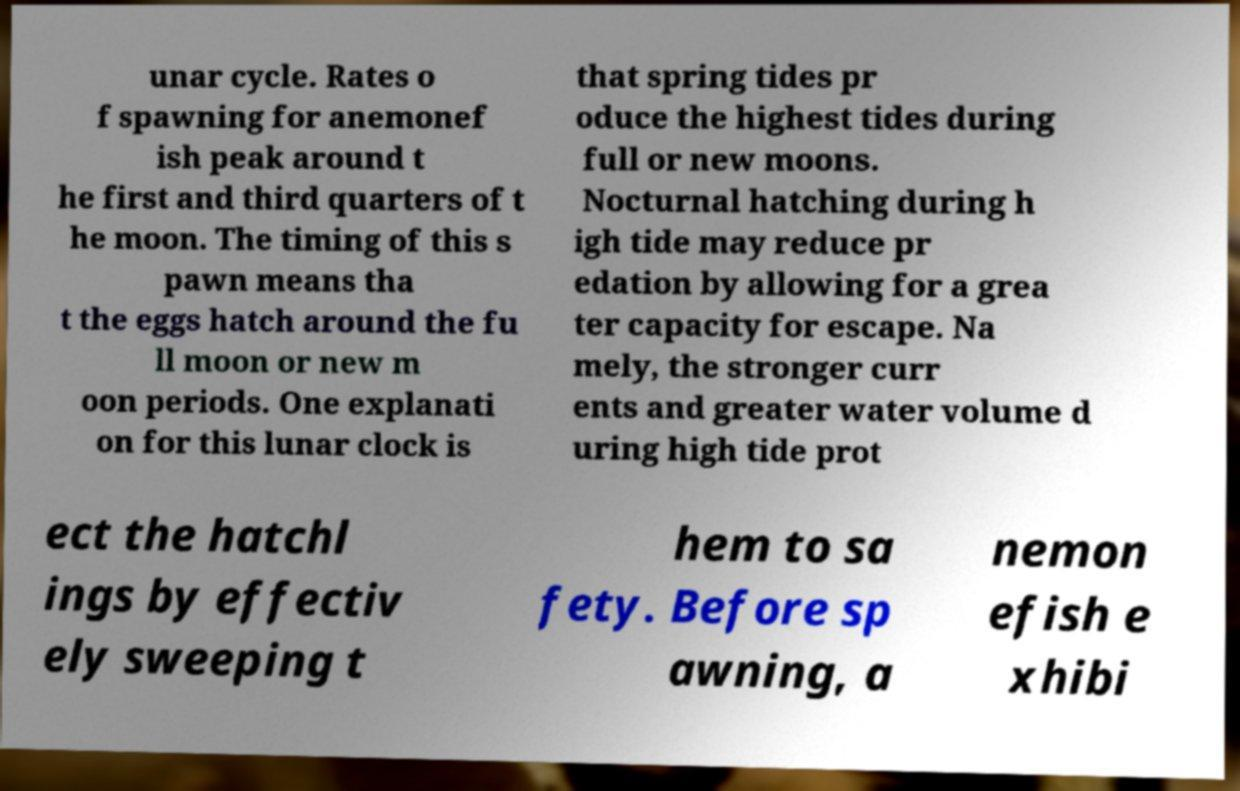Can you accurately transcribe the text from the provided image for me? unar cycle. Rates o f spawning for anemonef ish peak around t he first and third quarters of t he moon. The timing of this s pawn means tha t the eggs hatch around the fu ll moon or new m oon periods. One explanati on for this lunar clock is that spring tides pr oduce the highest tides during full or new moons. Nocturnal hatching during h igh tide may reduce pr edation by allowing for a grea ter capacity for escape. Na mely, the stronger curr ents and greater water volume d uring high tide prot ect the hatchl ings by effectiv ely sweeping t hem to sa fety. Before sp awning, a nemon efish e xhibi 